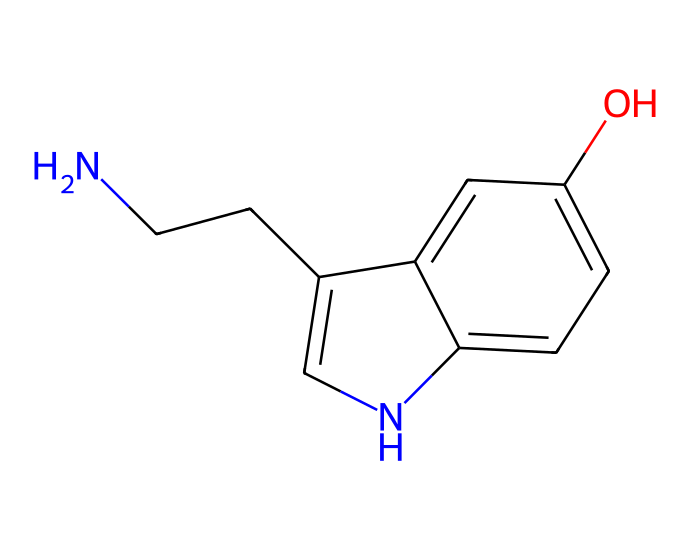How many carbon atoms are in the chemical structure? The SMILES representation has a series of 'c' characters indicating carbon atoms. Each lowercase 'c' refers to a carbon atom, and by counting them in the structure, you find there are 10 carbon atoms.
Answer: 10 What is the aromatic feature of this chemical structure? The structure contains benzene rings indicated by the alternating 'c' characters and the presence of 'n' for nitrogen in the ring structure, which suggests it has a bicyclic aromatic system.
Answer: aromatic What type of bond connects the nitrogen to the carbon chain? In the SMILES string, 'NCC' indicates that nitrogen is connected to carbon by a single bond (as implied by the absence of any number or other symbols indicating a different bond type).
Answer: single bond What role does serotonin play in psychological health? Although this isn't directly seen in the chemical structure, serotonin is widely known to regulate mood, and its dysfunction is linked to various psychological issues such as depression or anxiety.
Answer: mood regulation How many functional groups are present in the serotonin structure? By analyzing the structure, the hydroxyl (-OH) group on the ring and the amine (-NH) group connected to the carbon chain can be identified as functional groups in the serotonin molecule, totaling two functional groups.
Answer: 2 What kind of nitrogen configuration is present in this structure? The presence of nitrogen attached to aromatic carbons suggests that it is part of an aromatic amine structure, typically found in neurochemicals like serotonin, indicating a basic nitrogen configuration.
Answer: aromatic amine How does the hydroxyl group influence serotonin's properties? The hydroxyl group in the structure introduces hydrophilicity, enhancing its solubility in bodily fluids and facilitating interaction with neurotransmitter receptors, thus influencing its neurotransmission properties.
Answer: enhances solubility 